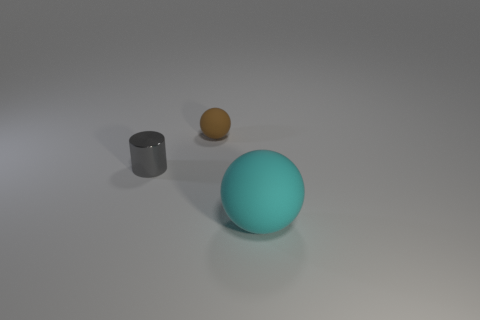The object that is both in front of the small rubber thing and on the left side of the big cyan thing has what shape?
Your response must be concise. Cylinder. Is there a gray cylinder that has the same material as the gray thing?
Offer a terse response. No. There is a object in front of the tiny metallic thing; what is its color?
Offer a very short reply. Cyan. There is a small gray metal object; is it the same shape as the matte thing that is on the left side of the large cyan sphere?
Provide a succinct answer. No. Is there a matte thing of the same color as the small ball?
Give a very brief answer. No. What is the size of the brown object that is made of the same material as the large cyan thing?
Provide a short and direct response. Small. Is the color of the small ball the same as the shiny cylinder?
Make the answer very short. No. There is a object that is left of the small brown matte ball; is its shape the same as the tiny brown matte object?
Give a very brief answer. No. What number of gray metallic cylinders have the same size as the cyan matte object?
Make the answer very short. 0. Are there any small brown things that are in front of the matte ball to the left of the cyan sphere?
Make the answer very short. No. 